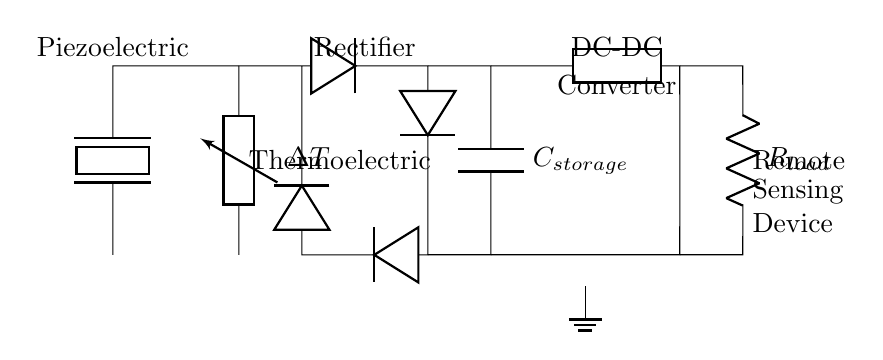What type of energy generation is used in this circuit? The circuit uses piezoelectric and thermoelectric elements for energy generation. Both elements convert different forms of energy into electrical energy.
Answer: Piezoelectric and thermoelectric What does the rectifier do in this circuit? The rectifier converts alternating current from the piezoelectric and thermoelectric elements into direct current for efficient storage and use.
Answer: Converts AC to DC What is the purpose of the capacitor labeled C_storage? The capacitor stores electrical energy generated by the energy harvesting components, allowing for a stable supply to the load over time.
Answer: Energy storage Which component allows for voltage regulation in this circuit? The DC-DC converter adjusts the voltage level of the stored energy to match the requirements of the load, ensuring proper functionality of the remote sensing device.
Answer: DC-DC converter What component connects to the remote sensing device? The resistor labeled R_load is connected to the remote sensing device, representing the load that utilizes the energy harvested.
Answer: Resistor Explain how the energy harvesting mechanism works in this circuit. The piezoelectric element generates voltage from mechanical stress while the thermoelectric element produces voltage from temperature differences. Both outputs feed into the rectifier, which converts AC to DC, then to the capacitor for storage and ultimately powers the load through the DC-DC converter.
Answer: Mechanically induced and temperature-induced energy conversion 